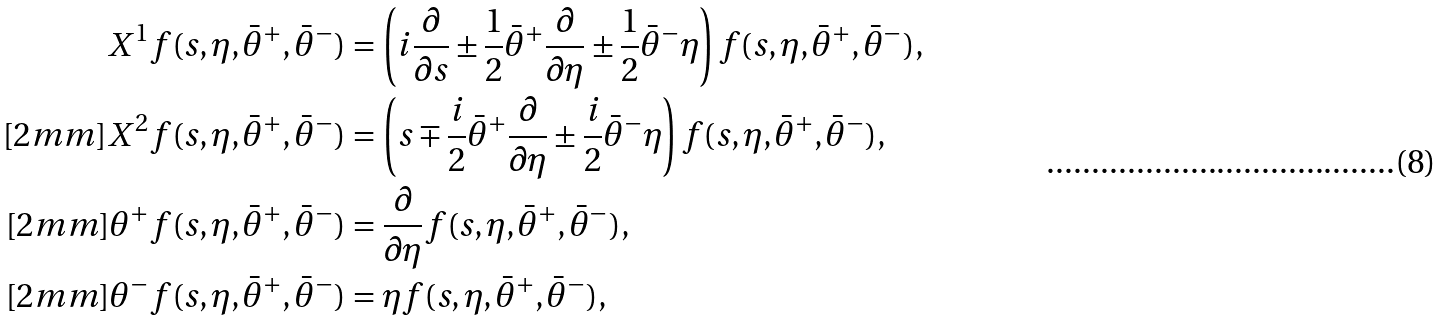Convert formula to latex. <formula><loc_0><loc_0><loc_500><loc_500>X ^ { 1 } f ( s , \eta , \bar { \theta } ^ { + } , \bar { \theta } ^ { - } ) & = \left ( i \frac { \partial } { \partial s } \pm \frac { 1 } { 2 } \bar { \theta } ^ { + } \frac { \partial } { \partial \eta } \pm \frac { 1 } { 2 } \bar { \theta } ^ { - } \eta \right ) f ( s , \eta , \bar { \theta } ^ { + } , \bar { \theta } ^ { - } ) , \\ [ 2 m m ] X ^ { 2 } f ( s , \eta , \bar { \theta } ^ { + } , \bar { \theta } ^ { - } ) & = \left ( s \mp \frac { i } { 2 } \bar { \theta } ^ { + } \frac { \partial } { \partial \eta } \pm \frac { i } { 2 } \bar { \theta } ^ { - } \eta \right ) f ( s , \eta , \bar { \theta } ^ { + } , \bar { \theta } ^ { - } ) , \\ [ 2 m m ] \theta ^ { + } f ( s , \eta , \bar { \theta } ^ { + } , \bar { \theta } ^ { - } ) & = \frac { \partial } { \partial \eta } f ( s , \eta , \bar { \theta } ^ { + } , \bar { \theta } ^ { - } ) , \\ [ 2 m m ] \theta ^ { - } f ( s , \eta , \bar { \theta } ^ { + } , \bar { \theta } ^ { - } ) & = \eta f ( s , \eta , \bar { \theta } ^ { + } , \bar { \theta } ^ { - } ) ,</formula> 